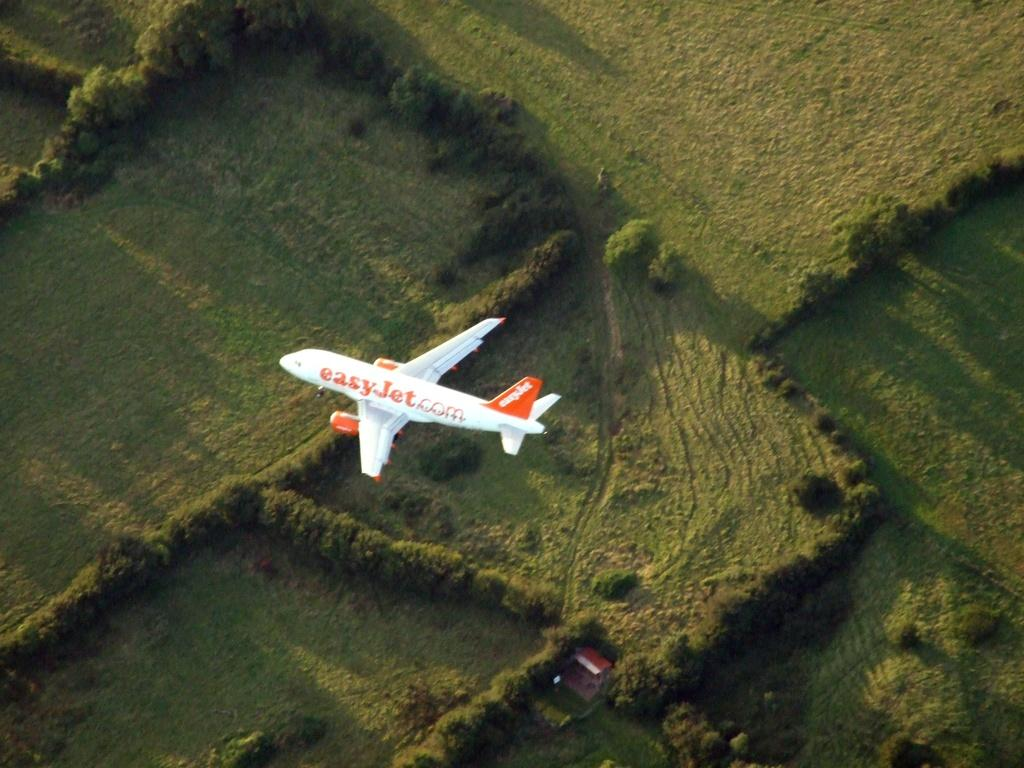Provide a one-sentence caption for the provided image. An "Easy Jet" plane flying over a grassy field. 